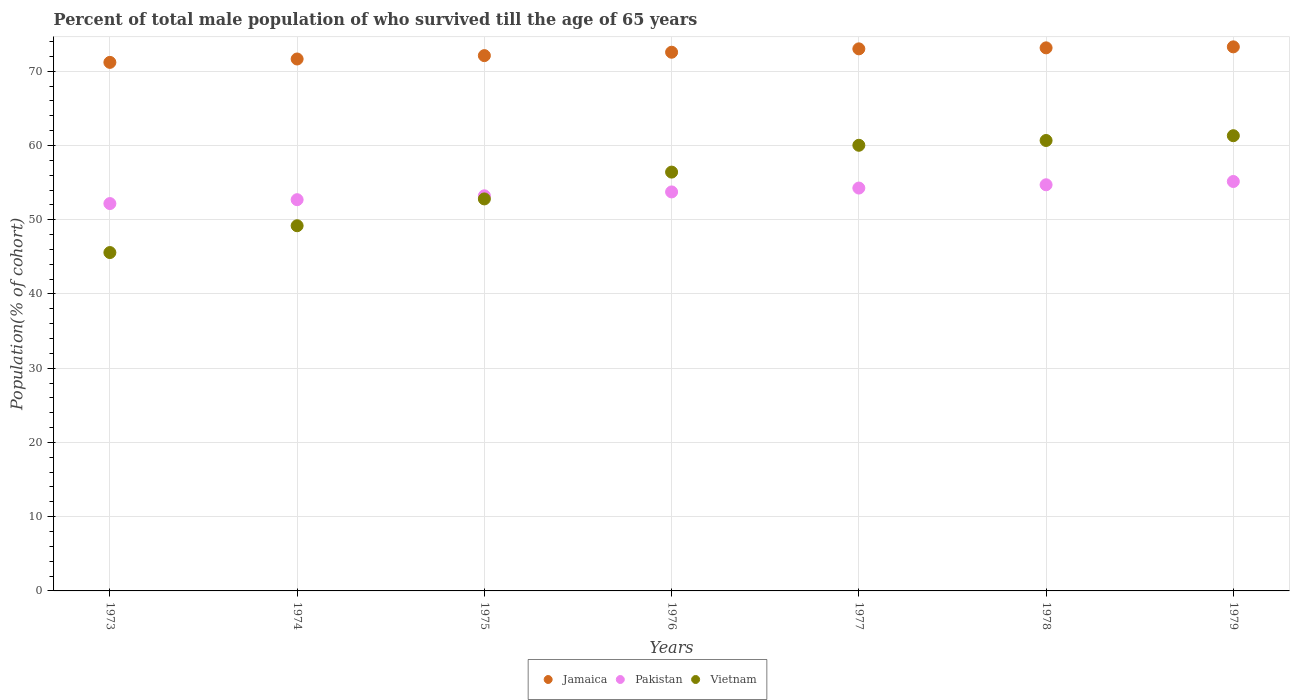How many different coloured dotlines are there?
Provide a short and direct response. 3. Is the number of dotlines equal to the number of legend labels?
Provide a succinct answer. Yes. What is the percentage of total male population who survived till the age of 65 years in Vietnam in 1977?
Provide a succinct answer. 60.03. Across all years, what is the maximum percentage of total male population who survived till the age of 65 years in Vietnam?
Your response must be concise. 61.32. Across all years, what is the minimum percentage of total male population who survived till the age of 65 years in Vietnam?
Give a very brief answer. 45.58. In which year was the percentage of total male population who survived till the age of 65 years in Vietnam maximum?
Give a very brief answer. 1979. What is the total percentage of total male population who survived till the age of 65 years in Pakistan in the graph?
Provide a short and direct response. 375.95. What is the difference between the percentage of total male population who survived till the age of 65 years in Pakistan in 1976 and that in 1979?
Provide a succinct answer. -1.41. What is the difference between the percentage of total male population who survived till the age of 65 years in Jamaica in 1976 and the percentage of total male population who survived till the age of 65 years in Vietnam in 1977?
Your answer should be compact. 12.53. What is the average percentage of total male population who survived till the age of 65 years in Vietnam per year?
Provide a short and direct response. 55.14. In the year 1978, what is the difference between the percentage of total male population who survived till the age of 65 years in Vietnam and percentage of total male population who survived till the age of 65 years in Jamaica?
Your answer should be very brief. -12.48. What is the ratio of the percentage of total male population who survived till the age of 65 years in Vietnam in 1973 to that in 1976?
Offer a terse response. 0.81. What is the difference between the highest and the second highest percentage of total male population who survived till the age of 65 years in Pakistan?
Keep it short and to the point. 0.44. What is the difference between the highest and the lowest percentage of total male population who survived till the age of 65 years in Vietnam?
Give a very brief answer. 15.74. In how many years, is the percentage of total male population who survived till the age of 65 years in Pakistan greater than the average percentage of total male population who survived till the age of 65 years in Pakistan taken over all years?
Make the answer very short. 4. Does the percentage of total male population who survived till the age of 65 years in Pakistan monotonically increase over the years?
Keep it short and to the point. Yes. Is the percentage of total male population who survived till the age of 65 years in Pakistan strictly greater than the percentage of total male population who survived till the age of 65 years in Vietnam over the years?
Your response must be concise. No. How many dotlines are there?
Give a very brief answer. 3. How many years are there in the graph?
Make the answer very short. 7. What is the difference between two consecutive major ticks on the Y-axis?
Your answer should be very brief. 10. Are the values on the major ticks of Y-axis written in scientific E-notation?
Give a very brief answer. No. Does the graph contain grids?
Your response must be concise. Yes. How many legend labels are there?
Keep it short and to the point. 3. What is the title of the graph?
Offer a very short reply. Percent of total male population of who survived till the age of 65 years. What is the label or title of the Y-axis?
Your response must be concise. Population(% of cohort). What is the Population(% of cohort) in Jamaica in 1973?
Offer a terse response. 71.19. What is the Population(% of cohort) in Pakistan in 1973?
Offer a very short reply. 52.18. What is the Population(% of cohort) of Vietnam in 1973?
Offer a very short reply. 45.58. What is the Population(% of cohort) of Jamaica in 1974?
Provide a succinct answer. 71.65. What is the Population(% of cohort) of Pakistan in 1974?
Provide a succinct answer. 52.7. What is the Population(% of cohort) of Vietnam in 1974?
Provide a short and direct response. 49.19. What is the Population(% of cohort) in Jamaica in 1975?
Ensure brevity in your answer.  72.1. What is the Population(% of cohort) of Pakistan in 1975?
Keep it short and to the point. 53.22. What is the Population(% of cohort) in Vietnam in 1975?
Ensure brevity in your answer.  52.8. What is the Population(% of cohort) of Jamaica in 1976?
Give a very brief answer. 72.56. What is the Population(% of cohort) in Pakistan in 1976?
Keep it short and to the point. 53.74. What is the Population(% of cohort) of Vietnam in 1976?
Make the answer very short. 56.41. What is the Population(% of cohort) of Jamaica in 1977?
Ensure brevity in your answer.  73.01. What is the Population(% of cohort) in Pakistan in 1977?
Provide a short and direct response. 54.26. What is the Population(% of cohort) in Vietnam in 1977?
Give a very brief answer. 60.03. What is the Population(% of cohort) of Jamaica in 1978?
Your response must be concise. 73.15. What is the Population(% of cohort) of Pakistan in 1978?
Make the answer very short. 54.71. What is the Population(% of cohort) of Vietnam in 1978?
Offer a terse response. 60.67. What is the Population(% of cohort) in Jamaica in 1979?
Make the answer very short. 73.28. What is the Population(% of cohort) of Pakistan in 1979?
Your answer should be compact. 55.15. What is the Population(% of cohort) in Vietnam in 1979?
Keep it short and to the point. 61.32. Across all years, what is the maximum Population(% of cohort) of Jamaica?
Your answer should be compact. 73.28. Across all years, what is the maximum Population(% of cohort) of Pakistan?
Your response must be concise. 55.15. Across all years, what is the maximum Population(% of cohort) in Vietnam?
Offer a very short reply. 61.32. Across all years, what is the minimum Population(% of cohort) in Jamaica?
Ensure brevity in your answer.  71.19. Across all years, what is the minimum Population(% of cohort) in Pakistan?
Your answer should be compact. 52.18. Across all years, what is the minimum Population(% of cohort) of Vietnam?
Offer a terse response. 45.58. What is the total Population(% of cohort) in Jamaica in the graph?
Your answer should be very brief. 506.95. What is the total Population(% of cohort) in Pakistan in the graph?
Offer a very short reply. 375.95. What is the total Population(% of cohort) in Vietnam in the graph?
Ensure brevity in your answer.  385.99. What is the difference between the Population(% of cohort) of Jamaica in 1973 and that in 1974?
Make the answer very short. -0.46. What is the difference between the Population(% of cohort) of Pakistan in 1973 and that in 1974?
Provide a short and direct response. -0.52. What is the difference between the Population(% of cohort) of Vietnam in 1973 and that in 1974?
Offer a terse response. -3.61. What is the difference between the Population(% of cohort) in Jamaica in 1973 and that in 1975?
Keep it short and to the point. -0.91. What is the difference between the Population(% of cohort) of Pakistan in 1973 and that in 1975?
Keep it short and to the point. -1.04. What is the difference between the Population(% of cohort) in Vietnam in 1973 and that in 1975?
Ensure brevity in your answer.  -7.22. What is the difference between the Population(% of cohort) in Jamaica in 1973 and that in 1976?
Provide a succinct answer. -1.37. What is the difference between the Population(% of cohort) in Pakistan in 1973 and that in 1976?
Your answer should be compact. -1.57. What is the difference between the Population(% of cohort) of Vietnam in 1973 and that in 1976?
Provide a short and direct response. -10.84. What is the difference between the Population(% of cohort) of Jamaica in 1973 and that in 1977?
Provide a succinct answer. -1.82. What is the difference between the Population(% of cohort) of Pakistan in 1973 and that in 1977?
Your answer should be very brief. -2.09. What is the difference between the Population(% of cohort) of Vietnam in 1973 and that in 1977?
Make the answer very short. -14.45. What is the difference between the Population(% of cohort) in Jamaica in 1973 and that in 1978?
Keep it short and to the point. -1.96. What is the difference between the Population(% of cohort) of Pakistan in 1973 and that in 1978?
Give a very brief answer. -2.53. What is the difference between the Population(% of cohort) of Vietnam in 1973 and that in 1978?
Provide a succinct answer. -15.09. What is the difference between the Population(% of cohort) of Jamaica in 1973 and that in 1979?
Make the answer very short. -2.09. What is the difference between the Population(% of cohort) of Pakistan in 1973 and that in 1979?
Your response must be concise. -2.97. What is the difference between the Population(% of cohort) of Vietnam in 1973 and that in 1979?
Give a very brief answer. -15.74. What is the difference between the Population(% of cohort) of Jamaica in 1974 and that in 1975?
Give a very brief answer. -0.46. What is the difference between the Population(% of cohort) in Pakistan in 1974 and that in 1975?
Make the answer very short. -0.52. What is the difference between the Population(% of cohort) in Vietnam in 1974 and that in 1975?
Keep it short and to the point. -3.61. What is the difference between the Population(% of cohort) in Jamaica in 1974 and that in 1976?
Your answer should be compact. -0.91. What is the difference between the Population(% of cohort) in Pakistan in 1974 and that in 1976?
Provide a short and direct response. -1.04. What is the difference between the Population(% of cohort) in Vietnam in 1974 and that in 1976?
Offer a terse response. -7.22. What is the difference between the Population(% of cohort) in Jamaica in 1974 and that in 1977?
Your answer should be compact. -1.37. What is the difference between the Population(% of cohort) in Pakistan in 1974 and that in 1977?
Your answer should be very brief. -1.57. What is the difference between the Population(% of cohort) in Vietnam in 1974 and that in 1977?
Ensure brevity in your answer.  -10.84. What is the difference between the Population(% of cohort) of Jamaica in 1974 and that in 1978?
Keep it short and to the point. -1.5. What is the difference between the Population(% of cohort) of Pakistan in 1974 and that in 1978?
Your answer should be compact. -2.01. What is the difference between the Population(% of cohort) of Vietnam in 1974 and that in 1978?
Offer a terse response. -11.48. What is the difference between the Population(% of cohort) of Jamaica in 1974 and that in 1979?
Provide a succinct answer. -1.63. What is the difference between the Population(% of cohort) in Pakistan in 1974 and that in 1979?
Provide a short and direct response. -2.45. What is the difference between the Population(% of cohort) of Vietnam in 1974 and that in 1979?
Provide a succinct answer. -12.13. What is the difference between the Population(% of cohort) of Jamaica in 1975 and that in 1976?
Your answer should be very brief. -0.46. What is the difference between the Population(% of cohort) of Pakistan in 1975 and that in 1976?
Offer a very short reply. -0.52. What is the difference between the Population(% of cohort) of Vietnam in 1975 and that in 1976?
Your response must be concise. -3.61. What is the difference between the Population(% of cohort) in Jamaica in 1975 and that in 1977?
Offer a terse response. -0.91. What is the difference between the Population(% of cohort) of Pakistan in 1975 and that in 1977?
Ensure brevity in your answer.  -1.04. What is the difference between the Population(% of cohort) of Vietnam in 1975 and that in 1977?
Keep it short and to the point. -7.22. What is the difference between the Population(% of cohort) of Jamaica in 1975 and that in 1978?
Offer a terse response. -1.05. What is the difference between the Population(% of cohort) of Pakistan in 1975 and that in 1978?
Provide a short and direct response. -1.49. What is the difference between the Population(% of cohort) of Vietnam in 1975 and that in 1978?
Provide a succinct answer. -7.87. What is the difference between the Population(% of cohort) in Jamaica in 1975 and that in 1979?
Make the answer very short. -1.18. What is the difference between the Population(% of cohort) of Pakistan in 1975 and that in 1979?
Offer a terse response. -1.93. What is the difference between the Population(% of cohort) in Vietnam in 1975 and that in 1979?
Offer a terse response. -8.51. What is the difference between the Population(% of cohort) of Jamaica in 1976 and that in 1977?
Provide a succinct answer. -0.46. What is the difference between the Population(% of cohort) of Pakistan in 1976 and that in 1977?
Make the answer very short. -0.52. What is the difference between the Population(% of cohort) of Vietnam in 1976 and that in 1977?
Your response must be concise. -3.61. What is the difference between the Population(% of cohort) in Jamaica in 1976 and that in 1978?
Ensure brevity in your answer.  -0.59. What is the difference between the Population(% of cohort) in Pakistan in 1976 and that in 1978?
Give a very brief answer. -0.96. What is the difference between the Population(% of cohort) of Vietnam in 1976 and that in 1978?
Ensure brevity in your answer.  -4.26. What is the difference between the Population(% of cohort) in Jamaica in 1976 and that in 1979?
Your answer should be very brief. -0.72. What is the difference between the Population(% of cohort) in Pakistan in 1976 and that in 1979?
Offer a terse response. -1.41. What is the difference between the Population(% of cohort) in Vietnam in 1976 and that in 1979?
Provide a short and direct response. -4.9. What is the difference between the Population(% of cohort) in Jamaica in 1977 and that in 1978?
Give a very brief answer. -0.13. What is the difference between the Population(% of cohort) of Pakistan in 1977 and that in 1978?
Your answer should be compact. -0.44. What is the difference between the Population(% of cohort) of Vietnam in 1977 and that in 1978?
Ensure brevity in your answer.  -0.65. What is the difference between the Population(% of cohort) of Jamaica in 1977 and that in 1979?
Your response must be concise. -0.27. What is the difference between the Population(% of cohort) in Pakistan in 1977 and that in 1979?
Your answer should be compact. -0.88. What is the difference between the Population(% of cohort) of Vietnam in 1977 and that in 1979?
Make the answer very short. -1.29. What is the difference between the Population(% of cohort) of Jamaica in 1978 and that in 1979?
Your response must be concise. -0.13. What is the difference between the Population(% of cohort) of Pakistan in 1978 and that in 1979?
Make the answer very short. -0.44. What is the difference between the Population(% of cohort) of Vietnam in 1978 and that in 1979?
Provide a short and direct response. -0.65. What is the difference between the Population(% of cohort) of Jamaica in 1973 and the Population(% of cohort) of Pakistan in 1974?
Provide a short and direct response. 18.49. What is the difference between the Population(% of cohort) of Jamaica in 1973 and the Population(% of cohort) of Vietnam in 1974?
Make the answer very short. 22. What is the difference between the Population(% of cohort) of Pakistan in 1973 and the Population(% of cohort) of Vietnam in 1974?
Offer a very short reply. 2.99. What is the difference between the Population(% of cohort) of Jamaica in 1973 and the Population(% of cohort) of Pakistan in 1975?
Your answer should be very brief. 17.97. What is the difference between the Population(% of cohort) in Jamaica in 1973 and the Population(% of cohort) in Vietnam in 1975?
Offer a very short reply. 18.39. What is the difference between the Population(% of cohort) in Pakistan in 1973 and the Population(% of cohort) in Vietnam in 1975?
Offer a very short reply. -0.63. What is the difference between the Population(% of cohort) in Jamaica in 1973 and the Population(% of cohort) in Pakistan in 1976?
Make the answer very short. 17.45. What is the difference between the Population(% of cohort) of Jamaica in 1973 and the Population(% of cohort) of Vietnam in 1976?
Your answer should be very brief. 14.78. What is the difference between the Population(% of cohort) of Pakistan in 1973 and the Population(% of cohort) of Vietnam in 1976?
Provide a succinct answer. -4.24. What is the difference between the Population(% of cohort) in Jamaica in 1973 and the Population(% of cohort) in Pakistan in 1977?
Make the answer very short. 16.93. What is the difference between the Population(% of cohort) of Jamaica in 1973 and the Population(% of cohort) of Vietnam in 1977?
Your answer should be very brief. 11.17. What is the difference between the Population(% of cohort) of Pakistan in 1973 and the Population(% of cohort) of Vietnam in 1977?
Your answer should be very brief. -7.85. What is the difference between the Population(% of cohort) of Jamaica in 1973 and the Population(% of cohort) of Pakistan in 1978?
Your answer should be very brief. 16.49. What is the difference between the Population(% of cohort) of Jamaica in 1973 and the Population(% of cohort) of Vietnam in 1978?
Your answer should be compact. 10.52. What is the difference between the Population(% of cohort) in Pakistan in 1973 and the Population(% of cohort) in Vietnam in 1978?
Offer a very short reply. -8.49. What is the difference between the Population(% of cohort) of Jamaica in 1973 and the Population(% of cohort) of Pakistan in 1979?
Make the answer very short. 16.04. What is the difference between the Population(% of cohort) in Jamaica in 1973 and the Population(% of cohort) in Vietnam in 1979?
Keep it short and to the point. 9.88. What is the difference between the Population(% of cohort) in Pakistan in 1973 and the Population(% of cohort) in Vietnam in 1979?
Provide a short and direct response. -9.14. What is the difference between the Population(% of cohort) of Jamaica in 1974 and the Population(% of cohort) of Pakistan in 1975?
Keep it short and to the point. 18.43. What is the difference between the Population(% of cohort) in Jamaica in 1974 and the Population(% of cohort) in Vietnam in 1975?
Ensure brevity in your answer.  18.85. What is the difference between the Population(% of cohort) of Pakistan in 1974 and the Population(% of cohort) of Vietnam in 1975?
Provide a succinct answer. -0.1. What is the difference between the Population(% of cohort) of Jamaica in 1974 and the Population(% of cohort) of Pakistan in 1976?
Provide a succinct answer. 17.91. What is the difference between the Population(% of cohort) of Jamaica in 1974 and the Population(% of cohort) of Vietnam in 1976?
Ensure brevity in your answer.  15.23. What is the difference between the Population(% of cohort) of Pakistan in 1974 and the Population(% of cohort) of Vietnam in 1976?
Keep it short and to the point. -3.72. What is the difference between the Population(% of cohort) of Jamaica in 1974 and the Population(% of cohort) of Pakistan in 1977?
Make the answer very short. 17.38. What is the difference between the Population(% of cohort) in Jamaica in 1974 and the Population(% of cohort) in Vietnam in 1977?
Ensure brevity in your answer.  11.62. What is the difference between the Population(% of cohort) in Pakistan in 1974 and the Population(% of cohort) in Vietnam in 1977?
Keep it short and to the point. -7.33. What is the difference between the Population(% of cohort) in Jamaica in 1974 and the Population(% of cohort) in Pakistan in 1978?
Provide a succinct answer. 16.94. What is the difference between the Population(% of cohort) in Jamaica in 1974 and the Population(% of cohort) in Vietnam in 1978?
Your answer should be very brief. 10.98. What is the difference between the Population(% of cohort) of Pakistan in 1974 and the Population(% of cohort) of Vietnam in 1978?
Your response must be concise. -7.97. What is the difference between the Population(% of cohort) in Jamaica in 1974 and the Population(% of cohort) in Pakistan in 1979?
Ensure brevity in your answer.  16.5. What is the difference between the Population(% of cohort) of Jamaica in 1974 and the Population(% of cohort) of Vietnam in 1979?
Keep it short and to the point. 10.33. What is the difference between the Population(% of cohort) of Pakistan in 1974 and the Population(% of cohort) of Vietnam in 1979?
Your answer should be compact. -8.62. What is the difference between the Population(% of cohort) of Jamaica in 1975 and the Population(% of cohort) of Pakistan in 1976?
Ensure brevity in your answer.  18.36. What is the difference between the Population(% of cohort) in Jamaica in 1975 and the Population(% of cohort) in Vietnam in 1976?
Make the answer very short. 15.69. What is the difference between the Population(% of cohort) in Pakistan in 1975 and the Population(% of cohort) in Vietnam in 1976?
Offer a very short reply. -3.19. What is the difference between the Population(% of cohort) in Jamaica in 1975 and the Population(% of cohort) in Pakistan in 1977?
Keep it short and to the point. 17.84. What is the difference between the Population(% of cohort) in Jamaica in 1975 and the Population(% of cohort) in Vietnam in 1977?
Provide a succinct answer. 12.08. What is the difference between the Population(% of cohort) in Pakistan in 1975 and the Population(% of cohort) in Vietnam in 1977?
Offer a very short reply. -6.81. What is the difference between the Population(% of cohort) of Jamaica in 1975 and the Population(% of cohort) of Pakistan in 1978?
Ensure brevity in your answer.  17.4. What is the difference between the Population(% of cohort) of Jamaica in 1975 and the Population(% of cohort) of Vietnam in 1978?
Keep it short and to the point. 11.43. What is the difference between the Population(% of cohort) of Pakistan in 1975 and the Population(% of cohort) of Vietnam in 1978?
Your answer should be compact. -7.45. What is the difference between the Population(% of cohort) in Jamaica in 1975 and the Population(% of cohort) in Pakistan in 1979?
Offer a terse response. 16.95. What is the difference between the Population(% of cohort) of Jamaica in 1975 and the Population(% of cohort) of Vietnam in 1979?
Your answer should be very brief. 10.79. What is the difference between the Population(% of cohort) in Pakistan in 1975 and the Population(% of cohort) in Vietnam in 1979?
Your answer should be very brief. -8.1. What is the difference between the Population(% of cohort) of Jamaica in 1976 and the Population(% of cohort) of Pakistan in 1977?
Provide a succinct answer. 18.29. What is the difference between the Population(% of cohort) in Jamaica in 1976 and the Population(% of cohort) in Vietnam in 1977?
Ensure brevity in your answer.  12.53. What is the difference between the Population(% of cohort) in Pakistan in 1976 and the Population(% of cohort) in Vietnam in 1977?
Your answer should be very brief. -6.28. What is the difference between the Population(% of cohort) of Jamaica in 1976 and the Population(% of cohort) of Pakistan in 1978?
Your answer should be compact. 17.85. What is the difference between the Population(% of cohort) of Jamaica in 1976 and the Population(% of cohort) of Vietnam in 1978?
Provide a succinct answer. 11.89. What is the difference between the Population(% of cohort) of Pakistan in 1976 and the Population(% of cohort) of Vietnam in 1978?
Your answer should be very brief. -6.93. What is the difference between the Population(% of cohort) of Jamaica in 1976 and the Population(% of cohort) of Pakistan in 1979?
Ensure brevity in your answer.  17.41. What is the difference between the Population(% of cohort) in Jamaica in 1976 and the Population(% of cohort) in Vietnam in 1979?
Make the answer very short. 11.24. What is the difference between the Population(% of cohort) of Pakistan in 1976 and the Population(% of cohort) of Vietnam in 1979?
Provide a succinct answer. -7.57. What is the difference between the Population(% of cohort) in Jamaica in 1977 and the Population(% of cohort) in Pakistan in 1978?
Ensure brevity in your answer.  18.31. What is the difference between the Population(% of cohort) in Jamaica in 1977 and the Population(% of cohort) in Vietnam in 1978?
Offer a terse response. 12.34. What is the difference between the Population(% of cohort) in Pakistan in 1977 and the Population(% of cohort) in Vietnam in 1978?
Provide a succinct answer. -6.41. What is the difference between the Population(% of cohort) of Jamaica in 1977 and the Population(% of cohort) of Pakistan in 1979?
Give a very brief answer. 17.87. What is the difference between the Population(% of cohort) of Jamaica in 1977 and the Population(% of cohort) of Vietnam in 1979?
Make the answer very short. 11.7. What is the difference between the Population(% of cohort) in Pakistan in 1977 and the Population(% of cohort) in Vietnam in 1979?
Offer a terse response. -7.05. What is the difference between the Population(% of cohort) in Jamaica in 1978 and the Population(% of cohort) in Pakistan in 1979?
Your answer should be very brief. 18. What is the difference between the Population(% of cohort) in Jamaica in 1978 and the Population(% of cohort) in Vietnam in 1979?
Provide a succinct answer. 11.83. What is the difference between the Population(% of cohort) of Pakistan in 1978 and the Population(% of cohort) of Vietnam in 1979?
Provide a succinct answer. -6.61. What is the average Population(% of cohort) of Jamaica per year?
Make the answer very short. 72.42. What is the average Population(% of cohort) of Pakistan per year?
Ensure brevity in your answer.  53.71. What is the average Population(% of cohort) in Vietnam per year?
Provide a succinct answer. 55.14. In the year 1973, what is the difference between the Population(% of cohort) in Jamaica and Population(% of cohort) in Pakistan?
Provide a short and direct response. 19.02. In the year 1973, what is the difference between the Population(% of cohort) of Jamaica and Population(% of cohort) of Vietnam?
Provide a short and direct response. 25.62. In the year 1973, what is the difference between the Population(% of cohort) in Pakistan and Population(% of cohort) in Vietnam?
Give a very brief answer. 6.6. In the year 1974, what is the difference between the Population(% of cohort) of Jamaica and Population(% of cohort) of Pakistan?
Offer a very short reply. 18.95. In the year 1974, what is the difference between the Population(% of cohort) of Jamaica and Population(% of cohort) of Vietnam?
Keep it short and to the point. 22.46. In the year 1974, what is the difference between the Population(% of cohort) in Pakistan and Population(% of cohort) in Vietnam?
Your answer should be very brief. 3.51. In the year 1975, what is the difference between the Population(% of cohort) in Jamaica and Population(% of cohort) in Pakistan?
Keep it short and to the point. 18.88. In the year 1975, what is the difference between the Population(% of cohort) of Jamaica and Population(% of cohort) of Vietnam?
Make the answer very short. 19.3. In the year 1975, what is the difference between the Population(% of cohort) in Pakistan and Population(% of cohort) in Vietnam?
Provide a succinct answer. 0.42. In the year 1976, what is the difference between the Population(% of cohort) in Jamaica and Population(% of cohort) in Pakistan?
Ensure brevity in your answer.  18.82. In the year 1976, what is the difference between the Population(% of cohort) in Jamaica and Population(% of cohort) in Vietnam?
Provide a succinct answer. 16.15. In the year 1976, what is the difference between the Population(% of cohort) of Pakistan and Population(% of cohort) of Vietnam?
Provide a succinct answer. -2.67. In the year 1977, what is the difference between the Population(% of cohort) in Jamaica and Population(% of cohort) in Pakistan?
Offer a terse response. 18.75. In the year 1977, what is the difference between the Population(% of cohort) of Jamaica and Population(% of cohort) of Vietnam?
Your answer should be very brief. 12.99. In the year 1977, what is the difference between the Population(% of cohort) in Pakistan and Population(% of cohort) in Vietnam?
Provide a succinct answer. -5.76. In the year 1978, what is the difference between the Population(% of cohort) of Jamaica and Population(% of cohort) of Pakistan?
Offer a very short reply. 18.44. In the year 1978, what is the difference between the Population(% of cohort) of Jamaica and Population(% of cohort) of Vietnam?
Your response must be concise. 12.48. In the year 1978, what is the difference between the Population(% of cohort) of Pakistan and Population(% of cohort) of Vietnam?
Provide a succinct answer. -5.96. In the year 1979, what is the difference between the Population(% of cohort) of Jamaica and Population(% of cohort) of Pakistan?
Your response must be concise. 18.13. In the year 1979, what is the difference between the Population(% of cohort) of Jamaica and Population(% of cohort) of Vietnam?
Provide a succinct answer. 11.97. In the year 1979, what is the difference between the Population(% of cohort) of Pakistan and Population(% of cohort) of Vietnam?
Offer a terse response. -6.17. What is the ratio of the Population(% of cohort) of Pakistan in 1973 to that in 1974?
Provide a succinct answer. 0.99. What is the ratio of the Population(% of cohort) in Vietnam in 1973 to that in 1974?
Your answer should be compact. 0.93. What is the ratio of the Population(% of cohort) in Jamaica in 1973 to that in 1975?
Your answer should be compact. 0.99. What is the ratio of the Population(% of cohort) in Pakistan in 1973 to that in 1975?
Give a very brief answer. 0.98. What is the ratio of the Population(% of cohort) in Vietnam in 1973 to that in 1975?
Your response must be concise. 0.86. What is the ratio of the Population(% of cohort) of Jamaica in 1973 to that in 1976?
Offer a terse response. 0.98. What is the ratio of the Population(% of cohort) of Pakistan in 1973 to that in 1976?
Provide a short and direct response. 0.97. What is the ratio of the Population(% of cohort) in Vietnam in 1973 to that in 1976?
Provide a succinct answer. 0.81. What is the ratio of the Population(% of cohort) in Pakistan in 1973 to that in 1977?
Make the answer very short. 0.96. What is the ratio of the Population(% of cohort) of Vietnam in 1973 to that in 1977?
Provide a succinct answer. 0.76. What is the ratio of the Population(% of cohort) in Jamaica in 1973 to that in 1978?
Make the answer very short. 0.97. What is the ratio of the Population(% of cohort) in Pakistan in 1973 to that in 1978?
Make the answer very short. 0.95. What is the ratio of the Population(% of cohort) in Vietnam in 1973 to that in 1978?
Keep it short and to the point. 0.75. What is the ratio of the Population(% of cohort) in Jamaica in 1973 to that in 1979?
Ensure brevity in your answer.  0.97. What is the ratio of the Population(% of cohort) in Pakistan in 1973 to that in 1979?
Keep it short and to the point. 0.95. What is the ratio of the Population(% of cohort) in Vietnam in 1973 to that in 1979?
Your response must be concise. 0.74. What is the ratio of the Population(% of cohort) of Jamaica in 1974 to that in 1975?
Give a very brief answer. 0.99. What is the ratio of the Population(% of cohort) in Pakistan in 1974 to that in 1975?
Give a very brief answer. 0.99. What is the ratio of the Population(% of cohort) of Vietnam in 1974 to that in 1975?
Offer a very short reply. 0.93. What is the ratio of the Population(% of cohort) in Jamaica in 1974 to that in 1976?
Your answer should be very brief. 0.99. What is the ratio of the Population(% of cohort) in Pakistan in 1974 to that in 1976?
Provide a succinct answer. 0.98. What is the ratio of the Population(% of cohort) of Vietnam in 1974 to that in 1976?
Offer a very short reply. 0.87. What is the ratio of the Population(% of cohort) in Jamaica in 1974 to that in 1977?
Keep it short and to the point. 0.98. What is the ratio of the Population(% of cohort) of Pakistan in 1974 to that in 1977?
Offer a terse response. 0.97. What is the ratio of the Population(% of cohort) in Vietnam in 1974 to that in 1977?
Offer a very short reply. 0.82. What is the ratio of the Population(% of cohort) in Jamaica in 1974 to that in 1978?
Your answer should be very brief. 0.98. What is the ratio of the Population(% of cohort) of Pakistan in 1974 to that in 1978?
Make the answer very short. 0.96. What is the ratio of the Population(% of cohort) in Vietnam in 1974 to that in 1978?
Ensure brevity in your answer.  0.81. What is the ratio of the Population(% of cohort) of Jamaica in 1974 to that in 1979?
Offer a terse response. 0.98. What is the ratio of the Population(% of cohort) of Pakistan in 1974 to that in 1979?
Make the answer very short. 0.96. What is the ratio of the Population(% of cohort) in Vietnam in 1974 to that in 1979?
Make the answer very short. 0.8. What is the ratio of the Population(% of cohort) in Jamaica in 1975 to that in 1976?
Your response must be concise. 0.99. What is the ratio of the Population(% of cohort) in Pakistan in 1975 to that in 1976?
Offer a very short reply. 0.99. What is the ratio of the Population(% of cohort) in Vietnam in 1975 to that in 1976?
Provide a succinct answer. 0.94. What is the ratio of the Population(% of cohort) of Jamaica in 1975 to that in 1977?
Your response must be concise. 0.99. What is the ratio of the Population(% of cohort) of Pakistan in 1975 to that in 1977?
Your answer should be compact. 0.98. What is the ratio of the Population(% of cohort) in Vietnam in 1975 to that in 1977?
Provide a succinct answer. 0.88. What is the ratio of the Population(% of cohort) of Jamaica in 1975 to that in 1978?
Your response must be concise. 0.99. What is the ratio of the Population(% of cohort) of Pakistan in 1975 to that in 1978?
Your answer should be compact. 0.97. What is the ratio of the Population(% of cohort) of Vietnam in 1975 to that in 1978?
Provide a short and direct response. 0.87. What is the ratio of the Population(% of cohort) in Jamaica in 1975 to that in 1979?
Ensure brevity in your answer.  0.98. What is the ratio of the Population(% of cohort) in Vietnam in 1975 to that in 1979?
Give a very brief answer. 0.86. What is the ratio of the Population(% of cohort) in Pakistan in 1976 to that in 1977?
Ensure brevity in your answer.  0.99. What is the ratio of the Population(% of cohort) of Vietnam in 1976 to that in 1977?
Provide a succinct answer. 0.94. What is the ratio of the Population(% of cohort) in Jamaica in 1976 to that in 1978?
Give a very brief answer. 0.99. What is the ratio of the Population(% of cohort) of Pakistan in 1976 to that in 1978?
Keep it short and to the point. 0.98. What is the ratio of the Population(% of cohort) in Vietnam in 1976 to that in 1978?
Offer a terse response. 0.93. What is the ratio of the Population(% of cohort) of Pakistan in 1976 to that in 1979?
Your response must be concise. 0.97. What is the ratio of the Population(% of cohort) of Vietnam in 1976 to that in 1979?
Make the answer very short. 0.92. What is the ratio of the Population(% of cohort) of Pakistan in 1977 to that in 1978?
Provide a short and direct response. 0.99. What is the ratio of the Population(% of cohort) of Vietnam in 1977 to that in 1978?
Your response must be concise. 0.99. What is the ratio of the Population(% of cohort) in Pakistan in 1977 to that in 1979?
Your answer should be compact. 0.98. What is the ratio of the Population(% of cohort) in Jamaica in 1978 to that in 1979?
Give a very brief answer. 1. What is the ratio of the Population(% of cohort) of Pakistan in 1978 to that in 1979?
Make the answer very short. 0.99. What is the ratio of the Population(% of cohort) of Vietnam in 1978 to that in 1979?
Provide a succinct answer. 0.99. What is the difference between the highest and the second highest Population(% of cohort) of Jamaica?
Make the answer very short. 0.13. What is the difference between the highest and the second highest Population(% of cohort) in Pakistan?
Your response must be concise. 0.44. What is the difference between the highest and the second highest Population(% of cohort) in Vietnam?
Offer a very short reply. 0.65. What is the difference between the highest and the lowest Population(% of cohort) in Jamaica?
Keep it short and to the point. 2.09. What is the difference between the highest and the lowest Population(% of cohort) of Pakistan?
Give a very brief answer. 2.97. What is the difference between the highest and the lowest Population(% of cohort) of Vietnam?
Give a very brief answer. 15.74. 